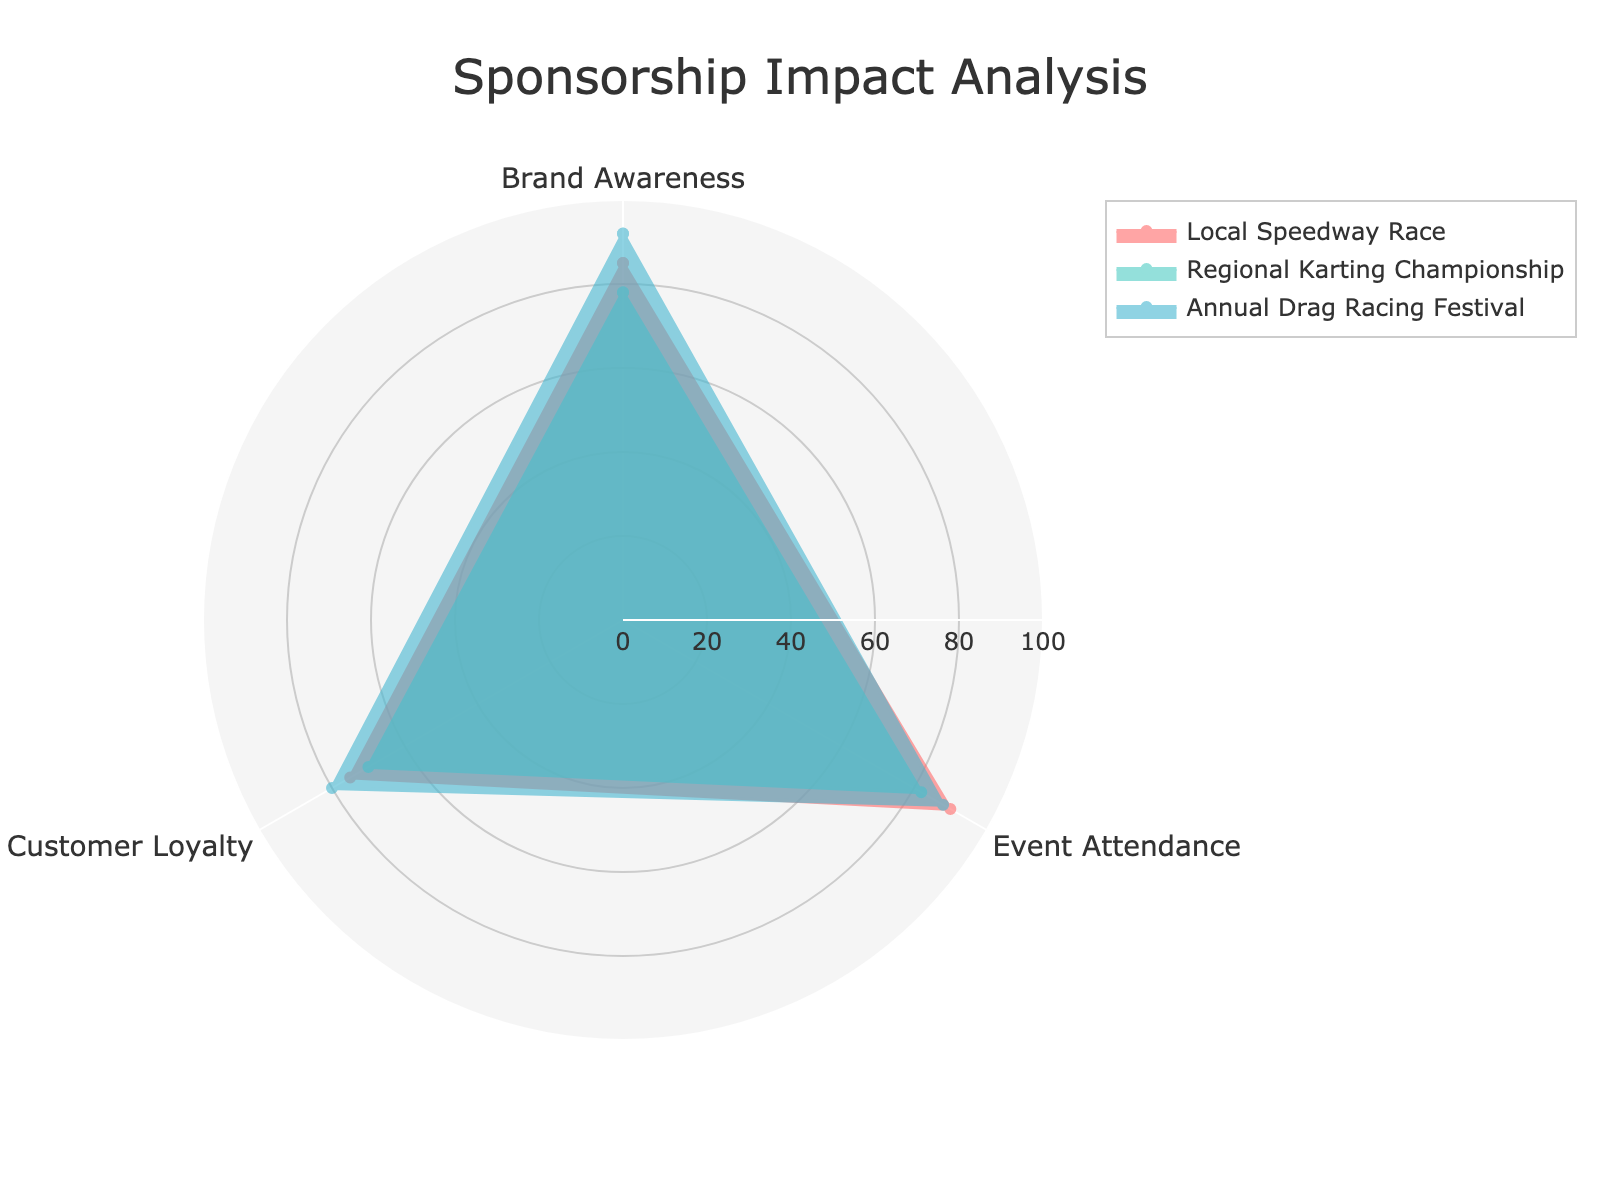What is the highest value for Brand Awareness among the events? Look at the "Brand Awareness" axis and identify the event with the highest value. The "Annual Drag Racing Festival" reaches 92, the highest on this axis.
Answer: Annual Drag Racing Festival Which event has the lowest Customer Loyalty value? Look at the "Customer Loyalty" axis and find the event with the lowest value. The "Regional Karting Championship" has a value of 70, which is the lowest.
Answer: Regional Karting Championship What is the average Event Attendance value across all events? Add up all Event Attendance values (90 + 82 + 88) and divide by the number of events (3). This calculation results in (260 / 3) which equals approximately 86.67.
Answer: 86.67 Which event performed better in Brand Awareness compared to Event Attendance? Compare the values in "Brand Awareness" and "Event Attendance" for each event. The "Local Speedway Race" has higher Brand Awareness (85 compared to 90 for Event Attendance), the "Regional Karting Championship" has lower Brand Awareness (78 compared to 82), and "Annual Drag Racing Festival" has higher Brand Awareness (92 compared to 88).
Answer: Annual Drag Racing Festival How does Customer Loyalty of Local Speedway Race compare to Regional Karting Championship? Compare the "Customer Loyalty" values of both events. Local Speedway Race has 75 and Regional Karting Championship has 70, therefore Local Speedway Race has a higher value.
Answer: Local Speedway Race is higher Which event shows the most balanced scores across all categories? Look for the event with the least variation in values across Brand Awareness, Event Attendance, and Customer Loyalty. The "Local Speedway Race" has values of 85, 90, and 75 respectively, which are relatively close compared to other events.
Answer: Local Speedway Race By how much does the Brand Awareness of Annual Drag Racing Festival exceed Local Speedway Race? Subtract the Brand Awareness of Local Speedway Race from Annual Drag Racing Festival (92 - 85).
Answer: 7 What is the total sum of Customer Loyalty values across all events? Add the Customer Loyalty values of all events (75 + 70 + 80). This sums up to 225.
Answer: 225 Which event has the most significant gap between Brand Awareness and Event Attendance? Calculate the difference between Brand Awareness and Event Attendance for each event: Local Speedway Race (90 - 85 = 5), Regional Karting Championship (82 - 78 = 4), and Annual Drag Racing Festival (92 - 88 = 4). The Local Speedway Race has the most significant gap of 5.
Answer: Local Speedway Race 